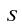Convert formula to latex. <formula><loc_0><loc_0><loc_500><loc_500>S</formula> 